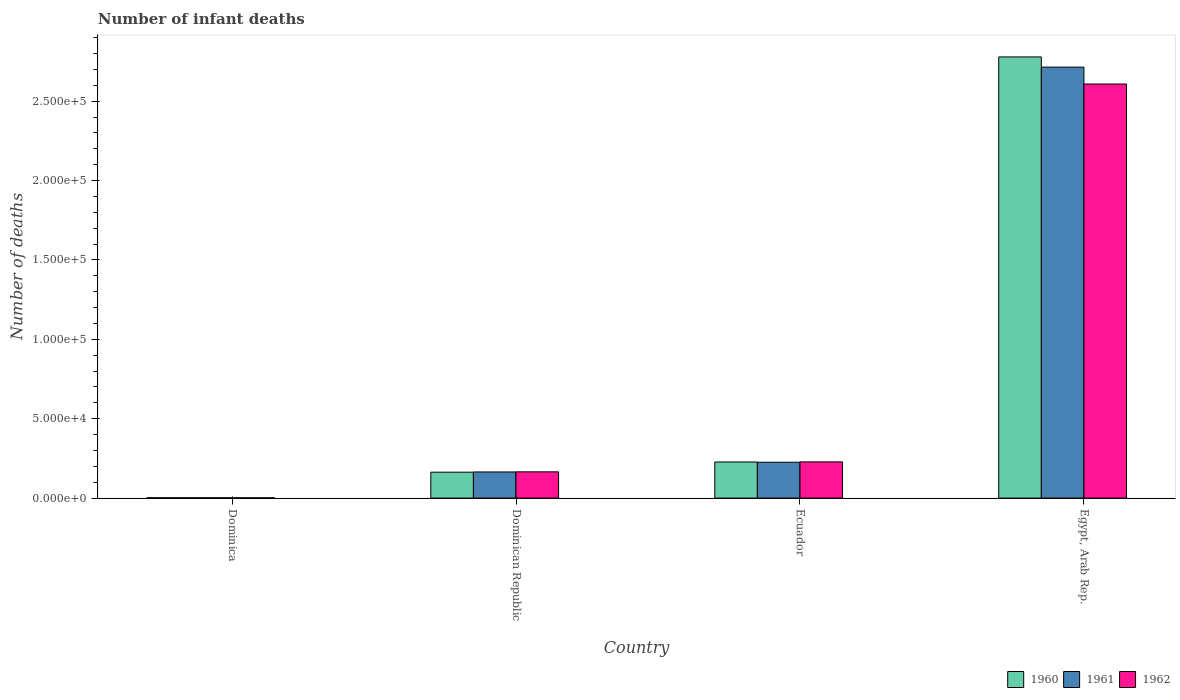How many different coloured bars are there?
Make the answer very short. 3. How many groups of bars are there?
Your answer should be very brief. 4. How many bars are there on the 1st tick from the left?
Keep it short and to the point. 3. How many bars are there on the 3rd tick from the right?
Give a very brief answer. 3. What is the label of the 1st group of bars from the left?
Provide a succinct answer. Dominica. What is the number of infant deaths in 1960 in Ecuador?
Keep it short and to the point. 2.27e+04. Across all countries, what is the maximum number of infant deaths in 1962?
Give a very brief answer. 2.61e+05. Across all countries, what is the minimum number of infant deaths in 1960?
Provide a succinct answer. 231. In which country was the number of infant deaths in 1960 maximum?
Provide a short and direct response. Egypt, Arab Rep. In which country was the number of infant deaths in 1962 minimum?
Provide a succinct answer. Dominica. What is the total number of infant deaths in 1962 in the graph?
Ensure brevity in your answer.  3.00e+05. What is the difference between the number of infant deaths in 1961 in Dominican Republic and that in Ecuador?
Give a very brief answer. -6135. What is the difference between the number of infant deaths in 1960 in Egypt, Arab Rep. and the number of infant deaths in 1961 in Dominican Republic?
Ensure brevity in your answer.  2.61e+05. What is the average number of infant deaths in 1962 per country?
Keep it short and to the point. 7.51e+04. What is the difference between the number of infant deaths of/in 1961 and number of infant deaths of/in 1962 in Egypt, Arab Rep.?
Your answer should be very brief. 1.06e+04. In how many countries, is the number of infant deaths in 1962 greater than 230000?
Make the answer very short. 1. What is the ratio of the number of infant deaths in 1960 in Dominica to that in Dominican Republic?
Provide a succinct answer. 0.01. Is the difference between the number of infant deaths in 1961 in Dominica and Dominican Republic greater than the difference between the number of infant deaths in 1962 in Dominica and Dominican Republic?
Provide a succinct answer. Yes. What is the difference between the highest and the second highest number of infant deaths in 1962?
Provide a succinct answer. -2.44e+05. What is the difference between the highest and the lowest number of infant deaths in 1960?
Give a very brief answer. 2.78e+05. Is the sum of the number of infant deaths in 1961 in Dominican Republic and Ecuador greater than the maximum number of infant deaths in 1960 across all countries?
Your answer should be very brief. No. What does the 1st bar from the left in Dominican Republic represents?
Offer a terse response. 1960. How many bars are there?
Provide a short and direct response. 12. Are all the bars in the graph horizontal?
Provide a short and direct response. No. Does the graph contain any zero values?
Your response must be concise. No. Does the graph contain grids?
Your answer should be compact. No. Where does the legend appear in the graph?
Offer a terse response. Bottom right. How many legend labels are there?
Give a very brief answer. 3. What is the title of the graph?
Keep it short and to the point. Number of infant deaths. What is the label or title of the X-axis?
Offer a very short reply. Country. What is the label or title of the Y-axis?
Offer a very short reply. Number of deaths. What is the Number of deaths in 1960 in Dominica?
Provide a short and direct response. 231. What is the Number of deaths in 1961 in Dominica?
Keep it short and to the point. 204. What is the Number of deaths in 1962 in Dominica?
Provide a short and direct response. 171. What is the Number of deaths in 1960 in Dominican Republic?
Ensure brevity in your answer.  1.63e+04. What is the Number of deaths of 1961 in Dominican Republic?
Provide a short and direct response. 1.65e+04. What is the Number of deaths of 1962 in Dominican Republic?
Ensure brevity in your answer.  1.65e+04. What is the Number of deaths in 1960 in Ecuador?
Your answer should be compact. 2.27e+04. What is the Number of deaths in 1961 in Ecuador?
Your answer should be very brief. 2.26e+04. What is the Number of deaths in 1962 in Ecuador?
Your answer should be very brief. 2.28e+04. What is the Number of deaths of 1960 in Egypt, Arab Rep.?
Offer a very short reply. 2.78e+05. What is the Number of deaths in 1961 in Egypt, Arab Rep.?
Give a very brief answer. 2.71e+05. What is the Number of deaths of 1962 in Egypt, Arab Rep.?
Provide a succinct answer. 2.61e+05. Across all countries, what is the maximum Number of deaths in 1960?
Ensure brevity in your answer.  2.78e+05. Across all countries, what is the maximum Number of deaths in 1961?
Make the answer very short. 2.71e+05. Across all countries, what is the maximum Number of deaths in 1962?
Keep it short and to the point. 2.61e+05. Across all countries, what is the minimum Number of deaths in 1960?
Provide a succinct answer. 231. Across all countries, what is the minimum Number of deaths in 1961?
Offer a very short reply. 204. Across all countries, what is the minimum Number of deaths in 1962?
Provide a short and direct response. 171. What is the total Number of deaths of 1960 in the graph?
Give a very brief answer. 3.17e+05. What is the total Number of deaths in 1961 in the graph?
Provide a short and direct response. 3.11e+05. What is the total Number of deaths of 1962 in the graph?
Provide a short and direct response. 3.00e+05. What is the difference between the Number of deaths in 1960 in Dominica and that in Dominican Republic?
Your response must be concise. -1.61e+04. What is the difference between the Number of deaths of 1961 in Dominica and that in Dominican Republic?
Provide a short and direct response. -1.62e+04. What is the difference between the Number of deaths of 1962 in Dominica and that in Dominican Republic?
Offer a terse response. -1.64e+04. What is the difference between the Number of deaths in 1960 in Dominica and that in Ecuador?
Offer a very short reply. -2.25e+04. What is the difference between the Number of deaths in 1961 in Dominica and that in Ecuador?
Your response must be concise. -2.24e+04. What is the difference between the Number of deaths of 1962 in Dominica and that in Ecuador?
Give a very brief answer. -2.26e+04. What is the difference between the Number of deaths of 1960 in Dominica and that in Egypt, Arab Rep.?
Your response must be concise. -2.78e+05. What is the difference between the Number of deaths in 1961 in Dominica and that in Egypt, Arab Rep.?
Offer a very short reply. -2.71e+05. What is the difference between the Number of deaths of 1962 in Dominica and that in Egypt, Arab Rep.?
Offer a terse response. -2.61e+05. What is the difference between the Number of deaths in 1960 in Dominican Republic and that in Ecuador?
Your response must be concise. -6416. What is the difference between the Number of deaths of 1961 in Dominican Republic and that in Ecuador?
Keep it short and to the point. -6135. What is the difference between the Number of deaths of 1962 in Dominican Republic and that in Ecuador?
Keep it short and to the point. -6251. What is the difference between the Number of deaths of 1960 in Dominican Republic and that in Egypt, Arab Rep.?
Make the answer very short. -2.62e+05. What is the difference between the Number of deaths of 1961 in Dominican Republic and that in Egypt, Arab Rep.?
Make the answer very short. -2.55e+05. What is the difference between the Number of deaths of 1962 in Dominican Republic and that in Egypt, Arab Rep.?
Make the answer very short. -2.44e+05. What is the difference between the Number of deaths in 1960 in Ecuador and that in Egypt, Arab Rep.?
Give a very brief answer. -2.55e+05. What is the difference between the Number of deaths of 1961 in Ecuador and that in Egypt, Arab Rep.?
Provide a succinct answer. -2.49e+05. What is the difference between the Number of deaths in 1962 in Ecuador and that in Egypt, Arab Rep.?
Ensure brevity in your answer.  -2.38e+05. What is the difference between the Number of deaths of 1960 in Dominica and the Number of deaths of 1961 in Dominican Republic?
Your answer should be compact. -1.62e+04. What is the difference between the Number of deaths in 1960 in Dominica and the Number of deaths in 1962 in Dominican Republic?
Keep it short and to the point. -1.63e+04. What is the difference between the Number of deaths in 1961 in Dominica and the Number of deaths in 1962 in Dominican Republic?
Ensure brevity in your answer.  -1.63e+04. What is the difference between the Number of deaths of 1960 in Dominica and the Number of deaths of 1961 in Ecuador?
Your answer should be compact. -2.24e+04. What is the difference between the Number of deaths of 1960 in Dominica and the Number of deaths of 1962 in Ecuador?
Give a very brief answer. -2.26e+04. What is the difference between the Number of deaths of 1961 in Dominica and the Number of deaths of 1962 in Ecuador?
Ensure brevity in your answer.  -2.26e+04. What is the difference between the Number of deaths of 1960 in Dominica and the Number of deaths of 1961 in Egypt, Arab Rep.?
Your answer should be compact. -2.71e+05. What is the difference between the Number of deaths of 1960 in Dominica and the Number of deaths of 1962 in Egypt, Arab Rep.?
Offer a very short reply. -2.61e+05. What is the difference between the Number of deaths of 1961 in Dominica and the Number of deaths of 1962 in Egypt, Arab Rep.?
Your response must be concise. -2.61e+05. What is the difference between the Number of deaths of 1960 in Dominican Republic and the Number of deaths of 1961 in Ecuador?
Provide a succinct answer. -6273. What is the difference between the Number of deaths of 1960 in Dominican Republic and the Number of deaths of 1962 in Ecuador?
Ensure brevity in your answer.  -6475. What is the difference between the Number of deaths of 1961 in Dominican Republic and the Number of deaths of 1962 in Ecuador?
Provide a short and direct response. -6337. What is the difference between the Number of deaths in 1960 in Dominican Republic and the Number of deaths in 1961 in Egypt, Arab Rep.?
Offer a very short reply. -2.55e+05. What is the difference between the Number of deaths in 1960 in Dominican Republic and the Number of deaths in 1962 in Egypt, Arab Rep.?
Ensure brevity in your answer.  -2.44e+05. What is the difference between the Number of deaths of 1961 in Dominican Republic and the Number of deaths of 1962 in Egypt, Arab Rep.?
Your answer should be very brief. -2.44e+05. What is the difference between the Number of deaths in 1960 in Ecuador and the Number of deaths in 1961 in Egypt, Arab Rep.?
Keep it short and to the point. -2.49e+05. What is the difference between the Number of deaths of 1960 in Ecuador and the Number of deaths of 1962 in Egypt, Arab Rep.?
Your response must be concise. -2.38e+05. What is the difference between the Number of deaths in 1961 in Ecuador and the Number of deaths in 1962 in Egypt, Arab Rep.?
Offer a terse response. -2.38e+05. What is the average Number of deaths in 1960 per country?
Give a very brief answer. 7.93e+04. What is the average Number of deaths in 1961 per country?
Offer a very short reply. 7.77e+04. What is the average Number of deaths of 1962 per country?
Keep it short and to the point. 7.51e+04. What is the difference between the Number of deaths of 1960 and Number of deaths of 1962 in Dominica?
Provide a short and direct response. 60. What is the difference between the Number of deaths of 1961 and Number of deaths of 1962 in Dominica?
Your answer should be compact. 33. What is the difference between the Number of deaths of 1960 and Number of deaths of 1961 in Dominican Republic?
Your response must be concise. -138. What is the difference between the Number of deaths of 1960 and Number of deaths of 1962 in Dominican Republic?
Provide a succinct answer. -224. What is the difference between the Number of deaths of 1961 and Number of deaths of 1962 in Dominican Republic?
Make the answer very short. -86. What is the difference between the Number of deaths of 1960 and Number of deaths of 1961 in Ecuador?
Your answer should be very brief. 143. What is the difference between the Number of deaths in 1960 and Number of deaths in 1962 in Ecuador?
Provide a succinct answer. -59. What is the difference between the Number of deaths in 1961 and Number of deaths in 1962 in Ecuador?
Make the answer very short. -202. What is the difference between the Number of deaths in 1960 and Number of deaths in 1961 in Egypt, Arab Rep.?
Make the answer very short. 6414. What is the difference between the Number of deaths of 1960 and Number of deaths of 1962 in Egypt, Arab Rep.?
Make the answer very short. 1.70e+04. What is the difference between the Number of deaths in 1961 and Number of deaths in 1962 in Egypt, Arab Rep.?
Your answer should be compact. 1.06e+04. What is the ratio of the Number of deaths in 1960 in Dominica to that in Dominican Republic?
Your answer should be very brief. 0.01. What is the ratio of the Number of deaths of 1961 in Dominica to that in Dominican Republic?
Your answer should be very brief. 0.01. What is the ratio of the Number of deaths of 1962 in Dominica to that in Dominican Republic?
Your answer should be very brief. 0.01. What is the ratio of the Number of deaths in 1960 in Dominica to that in Ecuador?
Offer a terse response. 0.01. What is the ratio of the Number of deaths in 1961 in Dominica to that in Ecuador?
Give a very brief answer. 0.01. What is the ratio of the Number of deaths in 1962 in Dominica to that in Ecuador?
Your answer should be compact. 0.01. What is the ratio of the Number of deaths in 1960 in Dominica to that in Egypt, Arab Rep.?
Give a very brief answer. 0. What is the ratio of the Number of deaths in 1961 in Dominica to that in Egypt, Arab Rep.?
Your answer should be very brief. 0. What is the ratio of the Number of deaths in 1962 in Dominica to that in Egypt, Arab Rep.?
Provide a short and direct response. 0. What is the ratio of the Number of deaths of 1960 in Dominican Republic to that in Ecuador?
Offer a very short reply. 0.72. What is the ratio of the Number of deaths of 1961 in Dominican Republic to that in Ecuador?
Your response must be concise. 0.73. What is the ratio of the Number of deaths in 1962 in Dominican Republic to that in Ecuador?
Offer a terse response. 0.73. What is the ratio of the Number of deaths of 1960 in Dominican Republic to that in Egypt, Arab Rep.?
Your response must be concise. 0.06. What is the ratio of the Number of deaths in 1961 in Dominican Republic to that in Egypt, Arab Rep.?
Your answer should be compact. 0.06. What is the ratio of the Number of deaths of 1962 in Dominican Republic to that in Egypt, Arab Rep.?
Offer a terse response. 0.06. What is the ratio of the Number of deaths in 1960 in Ecuador to that in Egypt, Arab Rep.?
Give a very brief answer. 0.08. What is the ratio of the Number of deaths of 1961 in Ecuador to that in Egypt, Arab Rep.?
Give a very brief answer. 0.08. What is the ratio of the Number of deaths in 1962 in Ecuador to that in Egypt, Arab Rep.?
Keep it short and to the point. 0.09. What is the difference between the highest and the second highest Number of deaths in 1960?
Your response must be concise. 2.55e+05. What is the difference between the highest and the second highest Number of deaths of 1961?
Your answer should be very brief. 2.49e+05. What is the difference between the highest and the second highest Number of deaths in 1962?
Provide a short and direct response. 2.38e+05. What is the difference between the highest and the lowest Number of deaths of 1960?
Ensure brevity in your answer.  2.78e+05. What is the difference between the highest and the lowest Number of deaths in 1961?
Provide a short and direct response. 2.71e+05. What is the difference between the highest and the lowest Number of deaths in 1962?
Keep it short and to the point. 2.61e+05. 